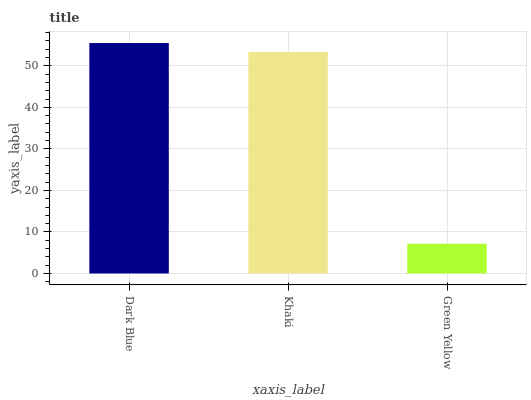Is Green Yellow the minimum?
Answer yes or no. Yes. Is Dark Blue the maximum?
Answer yes or no. Yes. Is Khaki the minimum?
Answer yes or no. No. Is Khaki the maximum?
Answer yes or no. No. Is Dark Blue greater than Khaki?
Answer yes or no. Yes. Is Khaki less than Dark Blue?
Answer yes or no. Yes. Is Khaki greater than Dark Blue?
Answer yes or no. No. Is Dark Blue less than Khaki?
Answer yes or no. No. Is Khaki the high median?
Answer yes or no. Yes. Is Khaki the low median?
Answer yes or no. Yes. Is Green Yellow the high median?
Answer yes or no. No. Is Dark Blue the low median?
Answer yes or no. No. 